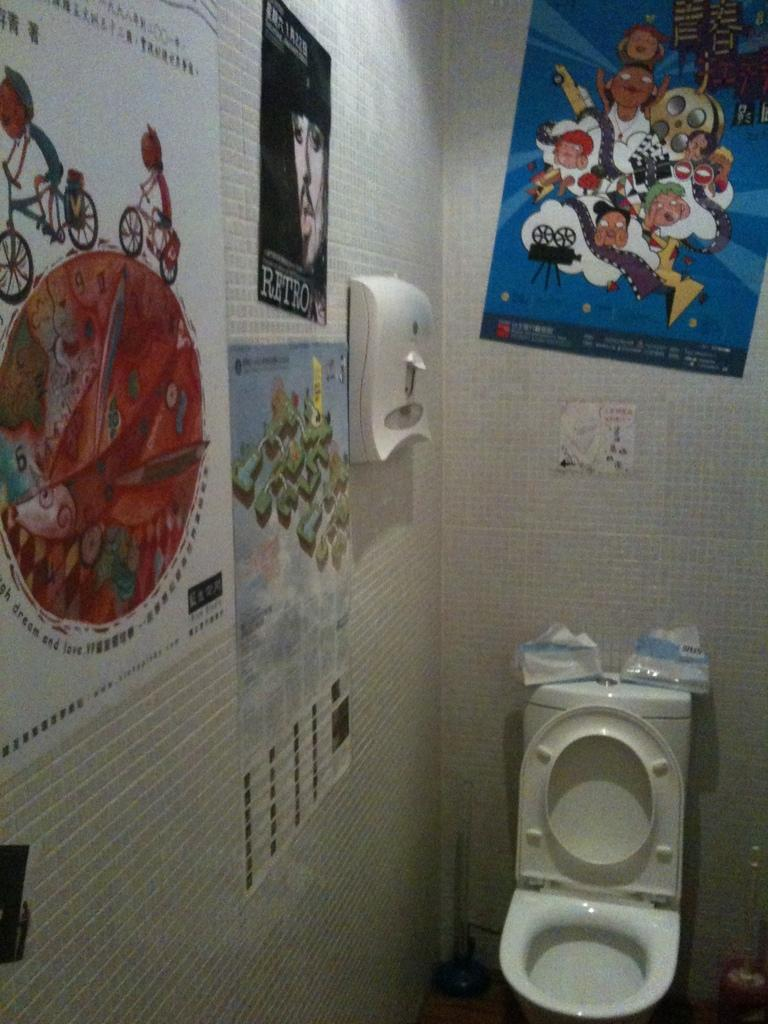What is located at the bottom of the image? There is a wash basin at the bottom of the image. What can be seen on the left side of the image? There are posters on the left side of the image, attached to the wall. Can you describe the poster in the background of the image? There is a poster in the background of the image, on the wall. How many beans are visible on the floor in the image? There are no beans visible on the floor in the image. What type of governor is mentioned in the poster in the background? There is no governor mentioned in the poster in the background, as it is not a political poster. 